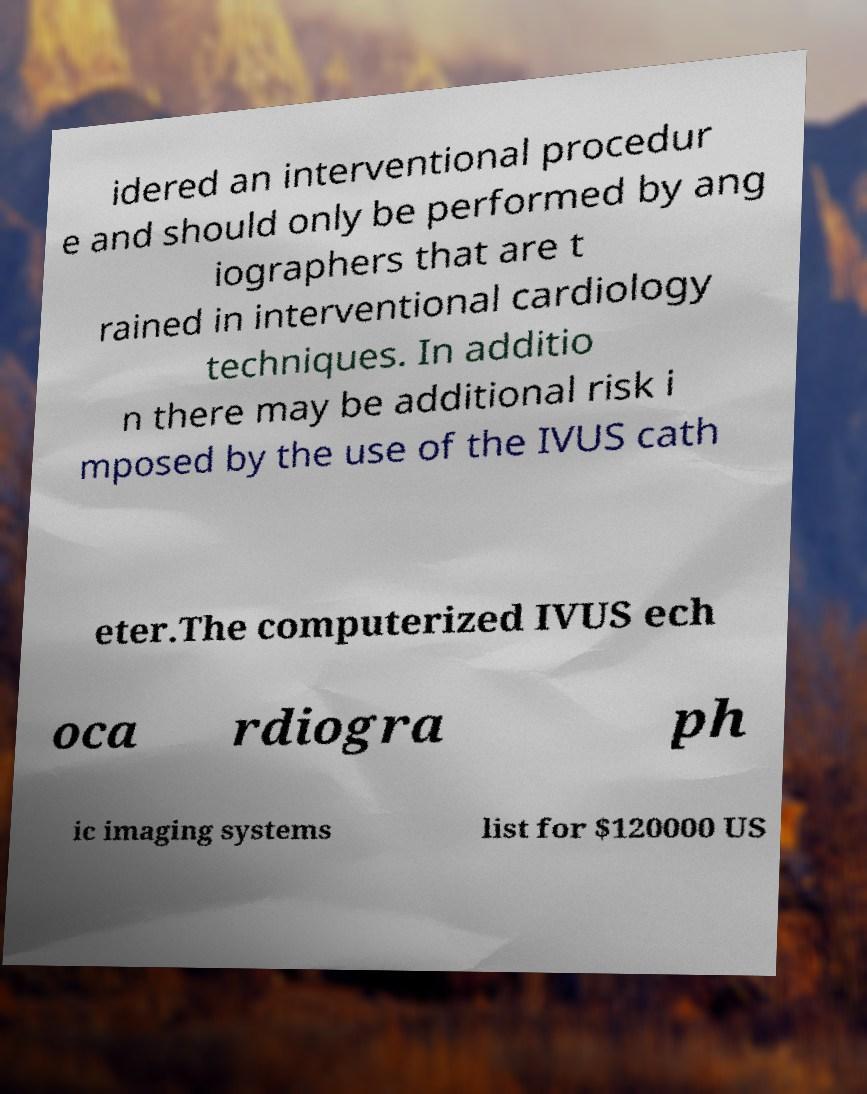There's text embedded in this image that I need extracted. Can you transcribe it verbatim? idered an interventional procedur e and should only be performed by ang iographers that are t rained in interventional cardiology techniques. In additio n there may be additional risk i mposed by the use of the IVUS cath eter.The computerized IVUS ech oca rdiogra ph ic imaging systems list for $120000 US 